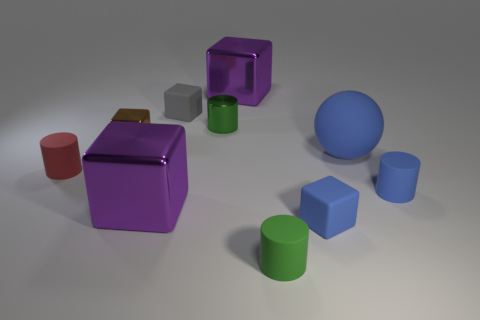Subtract all brown blocks. How many blocks are left? 4 Subtract all blue blocks. How many blocks are left? 4 Subtract all cyan cubes. Subtract all gray spheres. How many cubes are left? 5 Subtract all balls. How many objects are left? 9 Subtract all purple metallic objects. Subtract all small blue matte objects. How many objects are left? 6 Add 8 big blocks. How many big blocks are left? 10 Add 6 big red things. How many big red things exist? 6 Subtract 0 gray spheres. How many objects are left? 10 